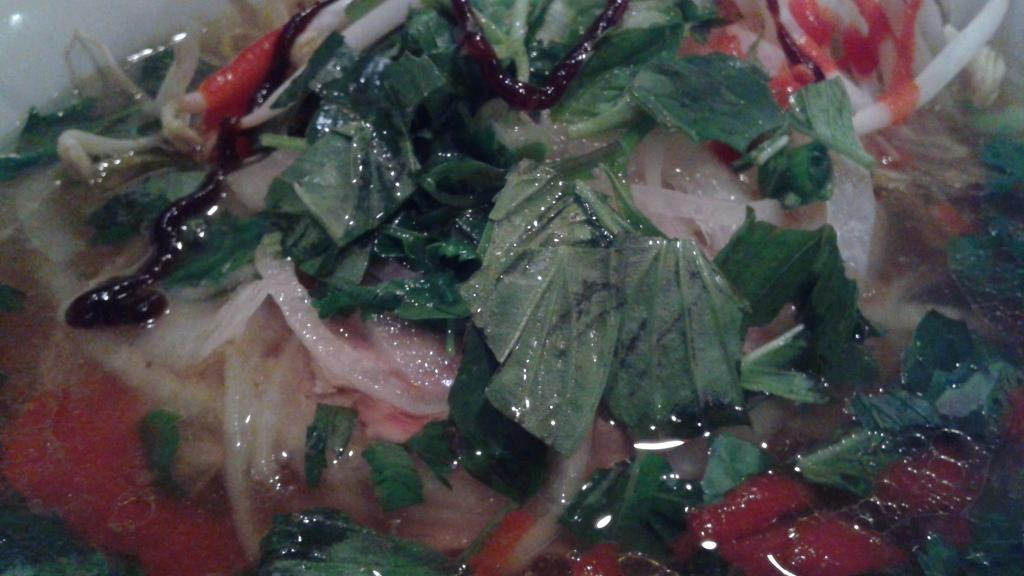What type of natural elements can be seen in the image? There are leaves in the image. What else can be seen in the image besides the leaves? There is water visible in the image. Are there any man-made objects or items in the image? Yes, there are food items in the image. What type of prose is being recited by the leaves in the image? There is no prose or recitation present in the image; it features leaves and water. Can you see any socks or feet in the image? There are no socks or feet visible in the image. 